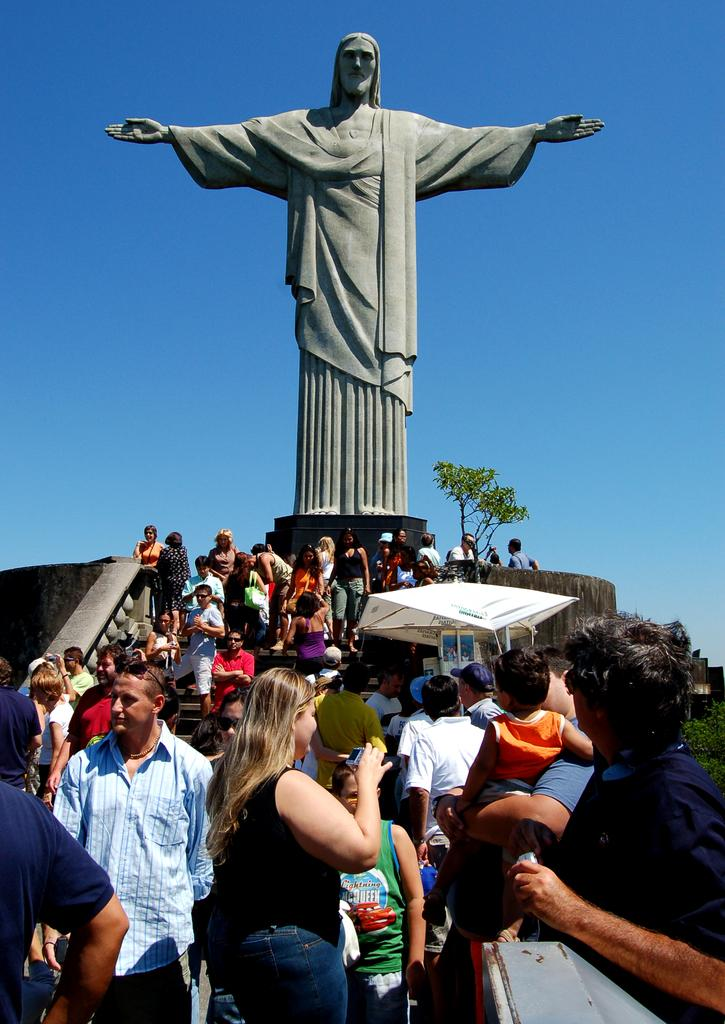What is the main subject in the image? There is a statue in the image. What else can be seen in the image besides the statue? There is a tent, a tree, a group of people, and the sky visible in the background. Where are the people located in the image? The people are on steps. What is the woman in the group holding? The woman is holding a camera in her hand. What type of waste can be seen being disposed of in the image? There is no waste present in the image. What are the people cooking in the image? There is no cooking activity depicted in the image. 